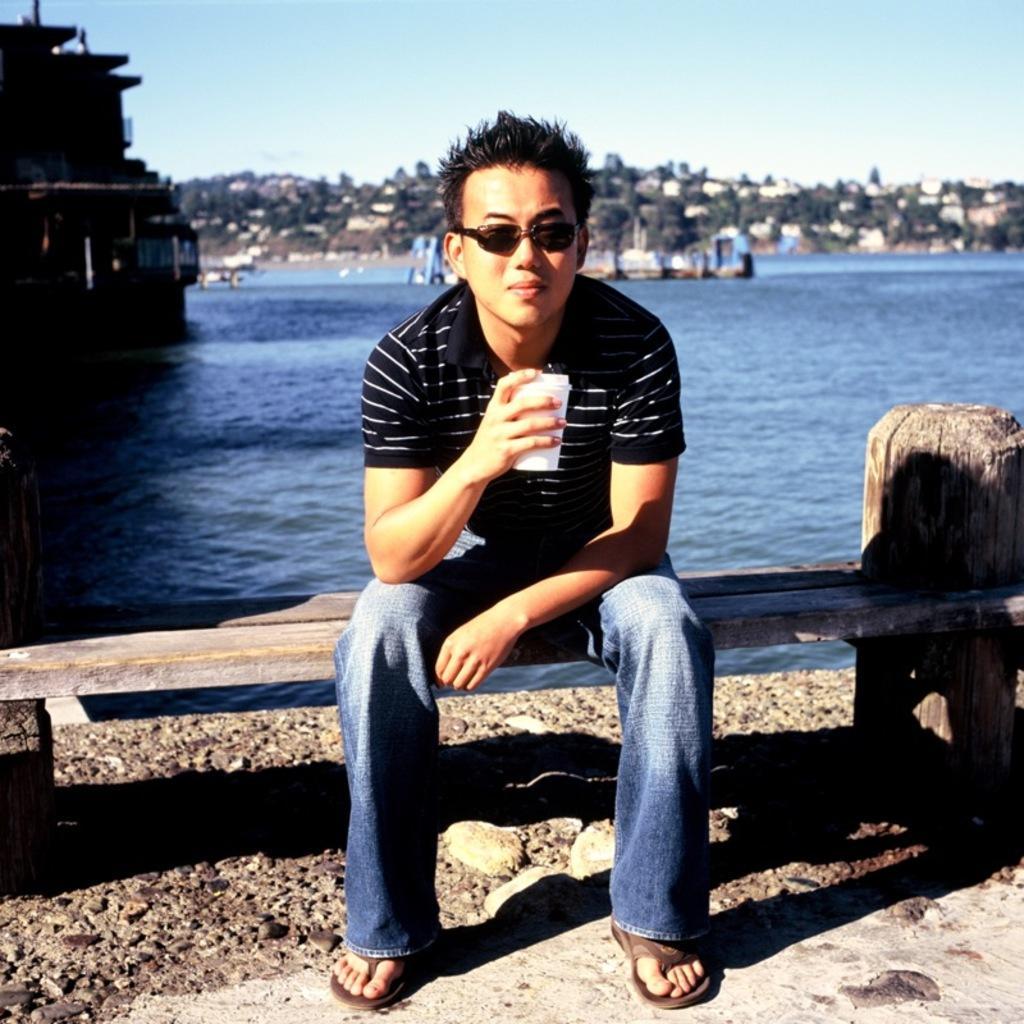Please provide a concise description of this image. This image consists of a man wearing a black T-shirt and holding a glass. He is sitting on a bench. It looks like it is made up of wood. In the background, there is water. At the top, there is sky. 